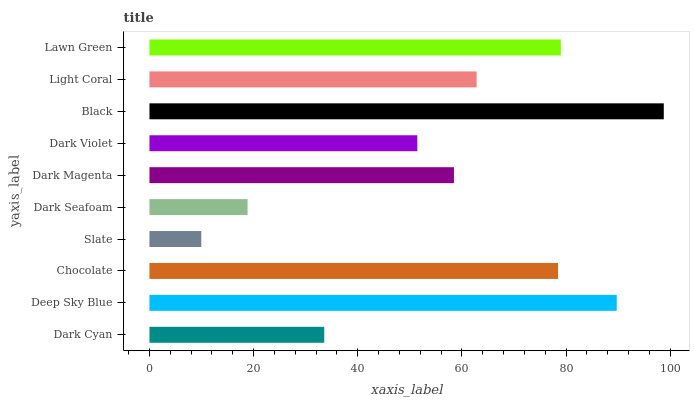Is Slate the minimum?
Answer yes or no. Yes. Is Black the maximum?
Answer yes or no. Yes. Is Deep Sky Blue the minimum?
Answer yes or no. No. Is Deep Sky Blue the maximum?
Answer yes or no. No. Is Deep Sky Blue greater than Dark Cyan?
Answer yes or no. Yes. Is Dark Cyan less than Deep Sky Blue?
Answer yes or no. Yes. Is Dark Cyan greater than Deep Sky Blue?
Answer yes or no. No. Is Deep Sky Blue less than Dark Cyan?
Answer yes or no. No. Is Light Coral the high median?
Answer yes or no. Yes. Is Dark Magenta the low median?
Answer yes or no. Yes. Is Dark Magenta the high median?
Answer yes or no. No. Is Dark Violet the low median?
Answer yes or no. No. 